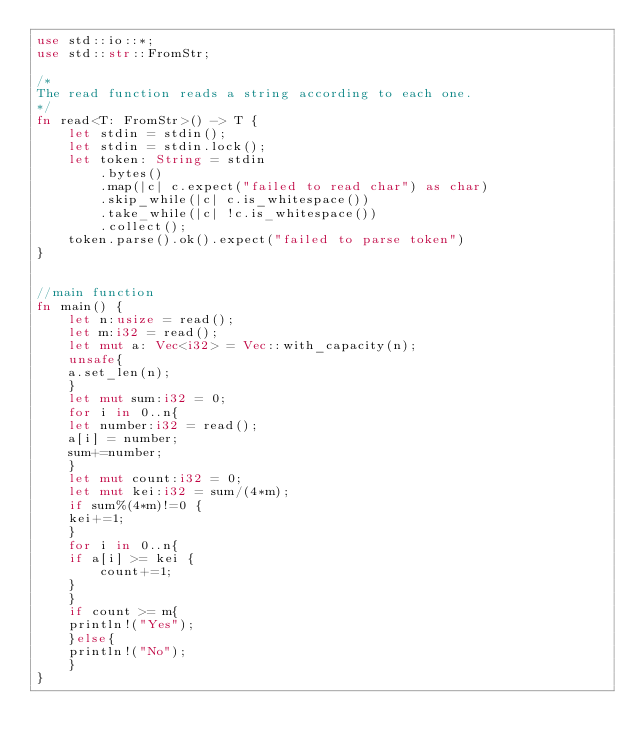Convert code to text. <code><loc_0><loc_0><loc_500><loc_500><_Rust_>use std::io::*;
use std::str::FromStr;
 
/* 
The read function reads a string according to each one. 
*/
fn read<T: FromStr>() -> T {
    let stdin = stdin();
    let stdin = stdin.lock();
    let token: String = stdin
        .bytes()
        .map(|c| c.expect("failed to read char") as char) 
        .skip_while(|c| c.is_whitespace())
        .take_while(|c| !c.is_whitespace())
        .collect();
    token.parse().ok().expect("failed to parse token")
}
 
 
//main function
fn main() {
    let n:usize = read();
    let m:i32 = read();
    let mut a: Vec<i32> = Vec::with_capacity(n);
    unsafe{
	a.set_len(n);
    }
    let mut sum:i32 = 0;
    for i in 0..n{
	let number:i32 = read();
	a[i] = number;
	sum+=number;
    }
    let mut count:i32 = 0;
    let mut kei:i32 = sum/(4*m);
    if sum%(4*m)!=0 {
	kei+=1;
    }
    for i in 0..n{
	if a[i] >= kei {
	    count+=1;
	}
    }
    if count >= m{
	println!("Yes");
    }else{
	println!("No");
    }
}
</code> 